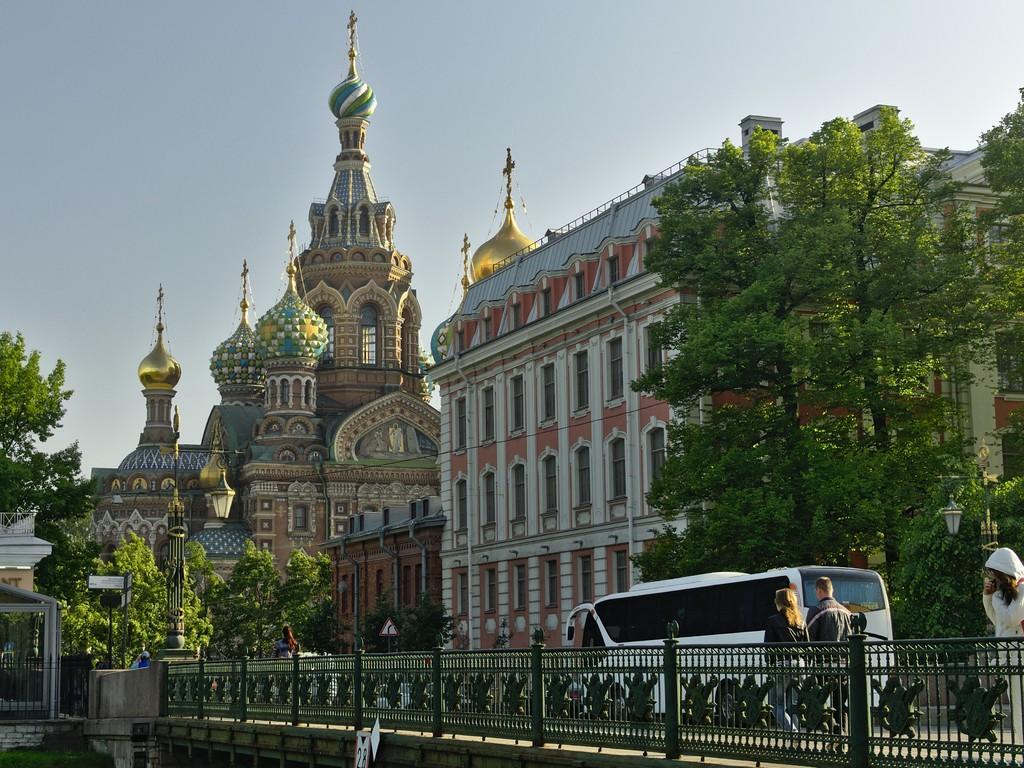Could you give a brief overview of what you see in this image? In this picture we can see a fence and people, vehicle on the road, here we can see buildings, trees, sign board, lights and some objects and we can see sky in the background. 